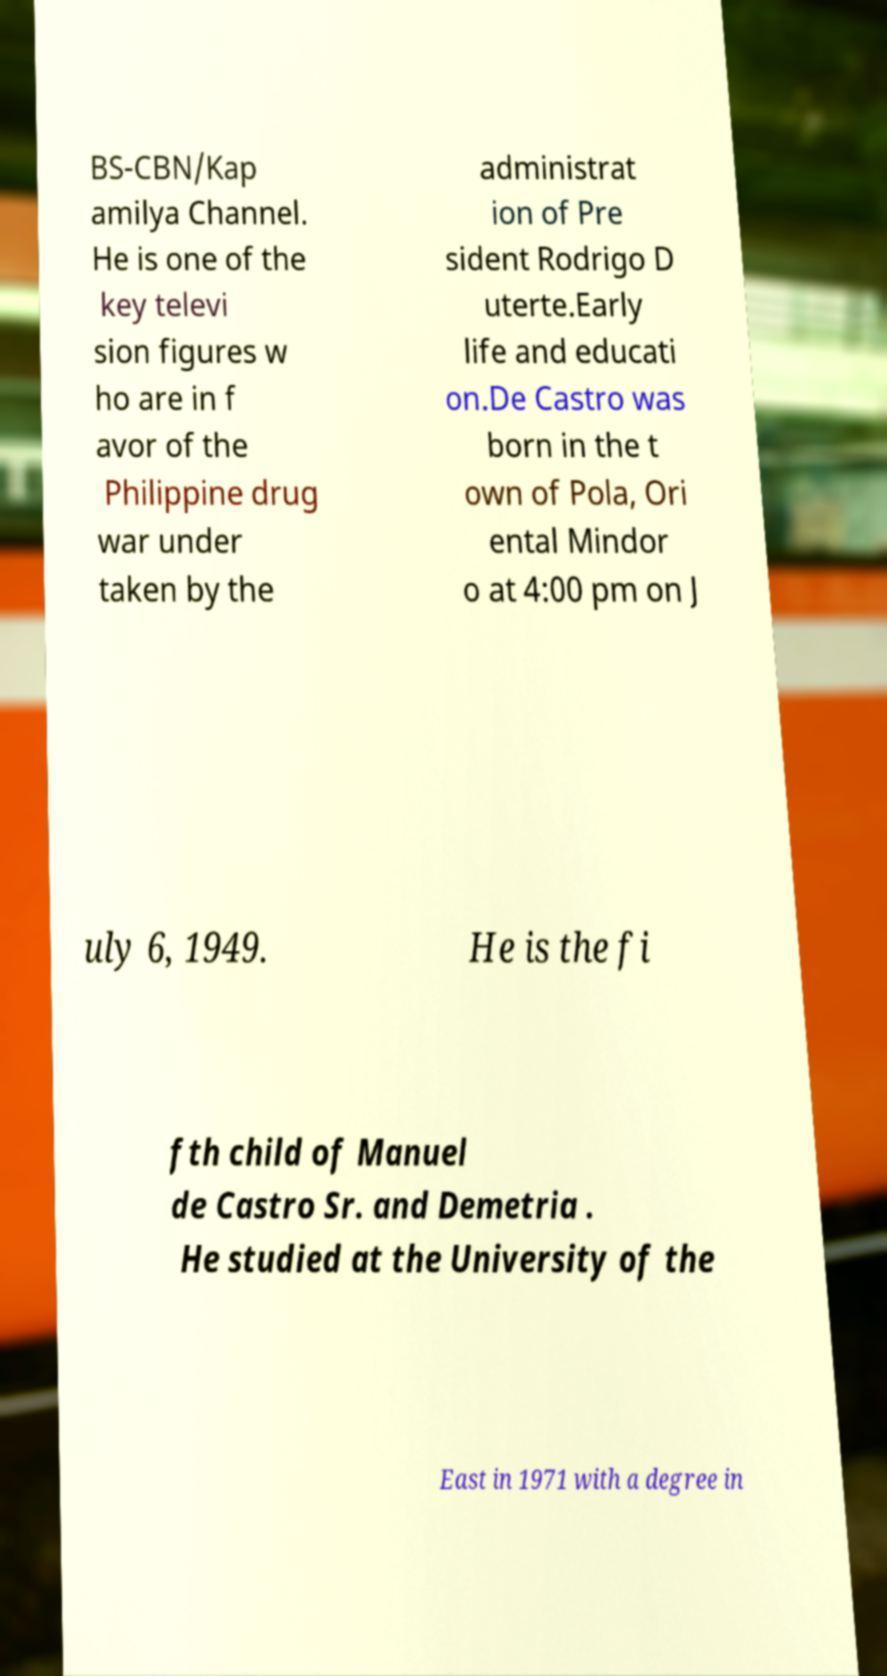Please read and relay the text visible in this image. What does it say? BS-CBN/Kap amilya Channel. He is one of the key televi sion figures w ho are in f avor of the Philippine drug war under taken by the administrat ion of Pre sident Rodrigo D uterte.Early life and educati on.De Castro was born in the t own of Pola, Ori ental Mindor o at 4:00 pm on J uly 6, 1949. He is the fi fth child of Manuel de Castro Sr. and Demetria . He studied at the University of the East in 1971 with a degree in 